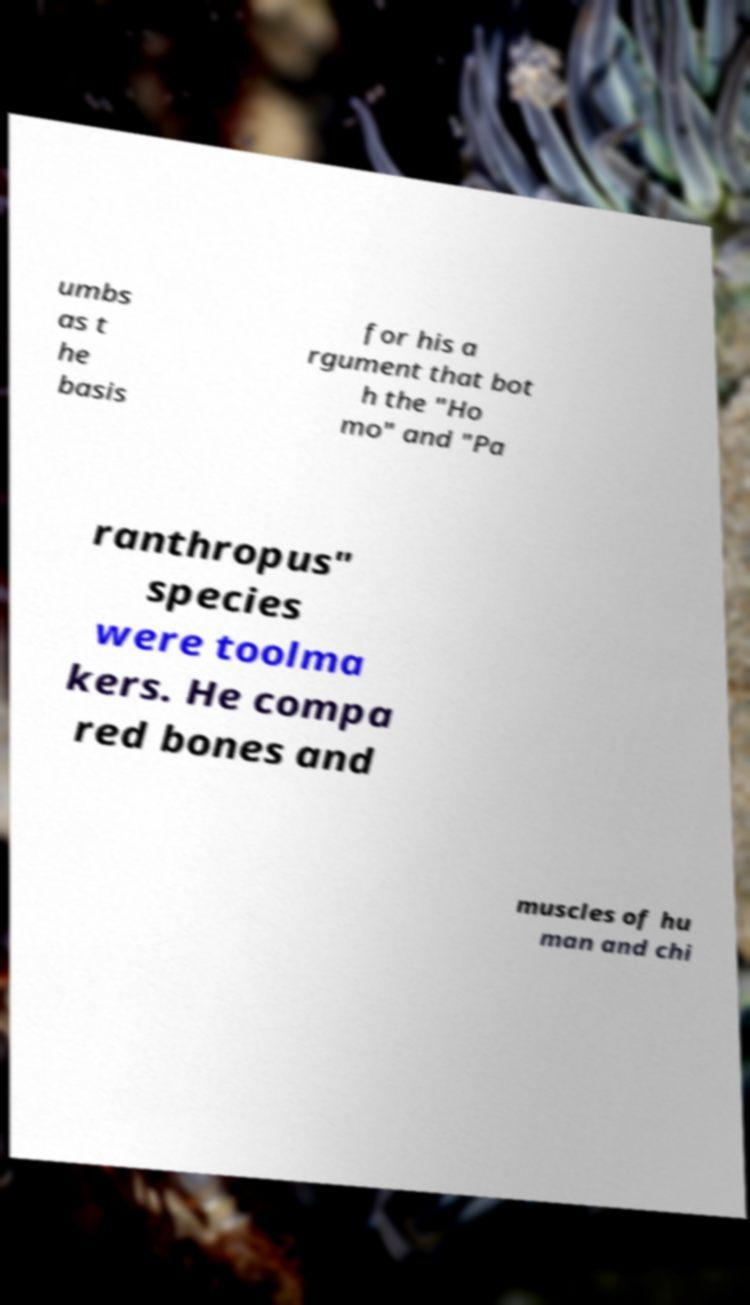Can you accurately transcribe the text from the provided image for me? umbs as t he basis for his a rgument that bot h the "Ho mo" and "Pa ranthropus" species were toolma kers. He compa red bones and muscles of hu man and chi 